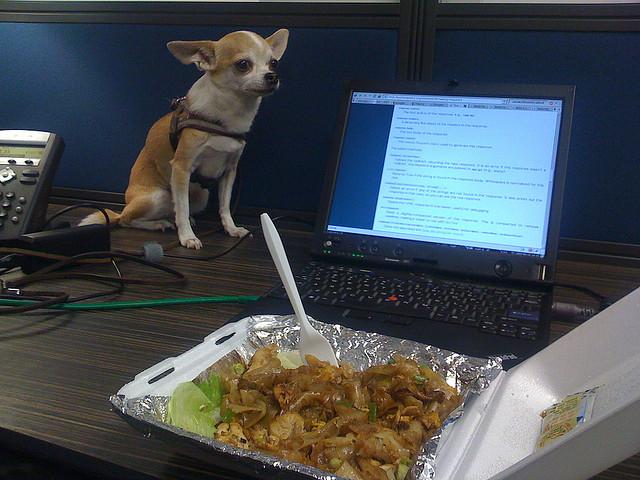Is the food tray lined with anything?
Answer briefly. Yes. Is the dog having dinner?
Quick response, please. No. What utensil is shown in this picture?
Give a very brief answer. Fork. 